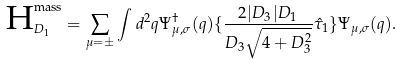<formula> <loc_0><loc_0><loc_500><loc_500>\text {H} ^ { \text {mass} } _ { D _ { 1 } } = \sum _ { \mu = \pm } \int d ^ { 2 } q \Psi ^ { \dag } _ { \mu , \sigma } ( q ) \{ \frac { 2 | D _ { 3 } | D _ { 1 } } { D _ { 3 } \sqrt { 4 + D ^ { 2 } _ { 3 } } } \hat { \tau } _ { 1 } \} \Psi _ { \mu , \sigma } ( q ) .</formula> 